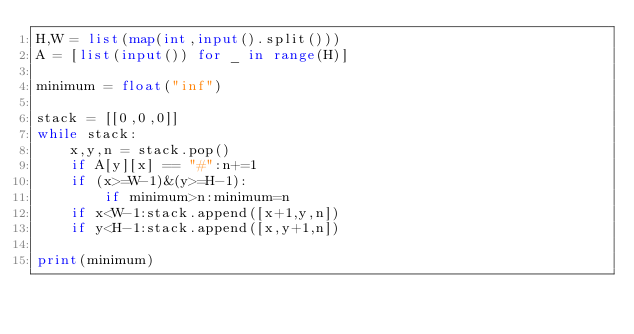<code> <loc_0><loc_0><loc_500><loc_500><_Python_>H,W = list(map(int,input().split()))
A = [list(input()) for _ in range(H)]

minimum = float("inf")

stack = [[0,0,0]]
while stack:
    x,y,n = stack.pop()
    if A[y][x] == "#":n+=1
    if (x>=W-1)&(y>=H-1):
        if minimum>n:minimum=n
    if x<W-1:stack.append([x+1,y,n])
    if y<H-1:stack.append([x,y+1,n])

print(minimum)</code> 